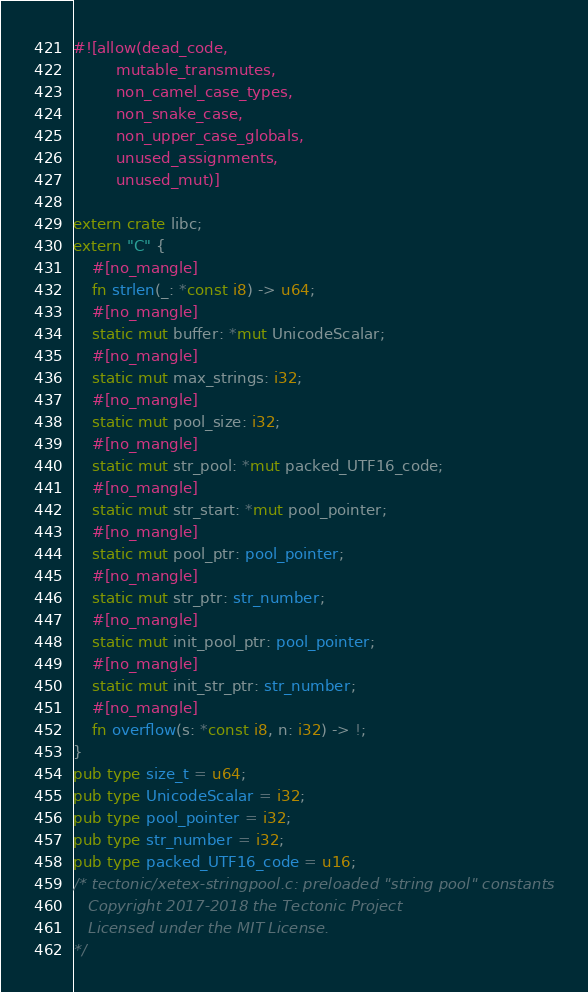Convert code to text. <code><loc_0><loc_0><loc_500><loc_500><_Rust_>#![allow(dead_code,
         mutable_transmutes,
         non_camel_case_types,
         non_snake_case,
         non_upper_case_globals,
         unused_assignments,
         unused_mut)]

extern crate libc;
extern "C" {
    #[no_mangle]
    fn strlen(_: *const i8) -> u64;
    #[no_mangle]
    static mut buffer: *mut UnicodeScalar;
    #[no_mangle]
    static mut max_strings: i32;
    #[no_mangle]
    static mut pool_size: i32;
    #[no_mangle]
    static mut str_pool: *mut packed_UTF16_code;
    #[no_mangle]
    static mut str_start: *mut pool_pointer;
    #[no_mangle]
    static mut pool_ptr: pool_pointer;
    #[no_mangle]
    static mut str_ptr: str_number;
    #[no_mangle]
    static mut init_pool_ptr: pool_pointer;
    #[no_mangle]
    static mut init_str_ptr: str_number;
    #[no_mangle]
    fn overflow(s: *const i8, n: i32) -> !;
}
pub type size_t = u64;
pub type UnicodeScalar = i32;
pub type pool_pointer = i32;
pub type str_number = i32;
pub type packed_UTF16_code = u16;
/* tectonic/xetex-stringpool.c: preloaded "string pool" constants
   Copyright 2017-2018 the Tectonic Project
   Licensed under the MIT License.
*/</code> 